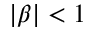<formula> <loc_0><loc_0><loc_500><loc_500>| \beta | < 1</formula> 